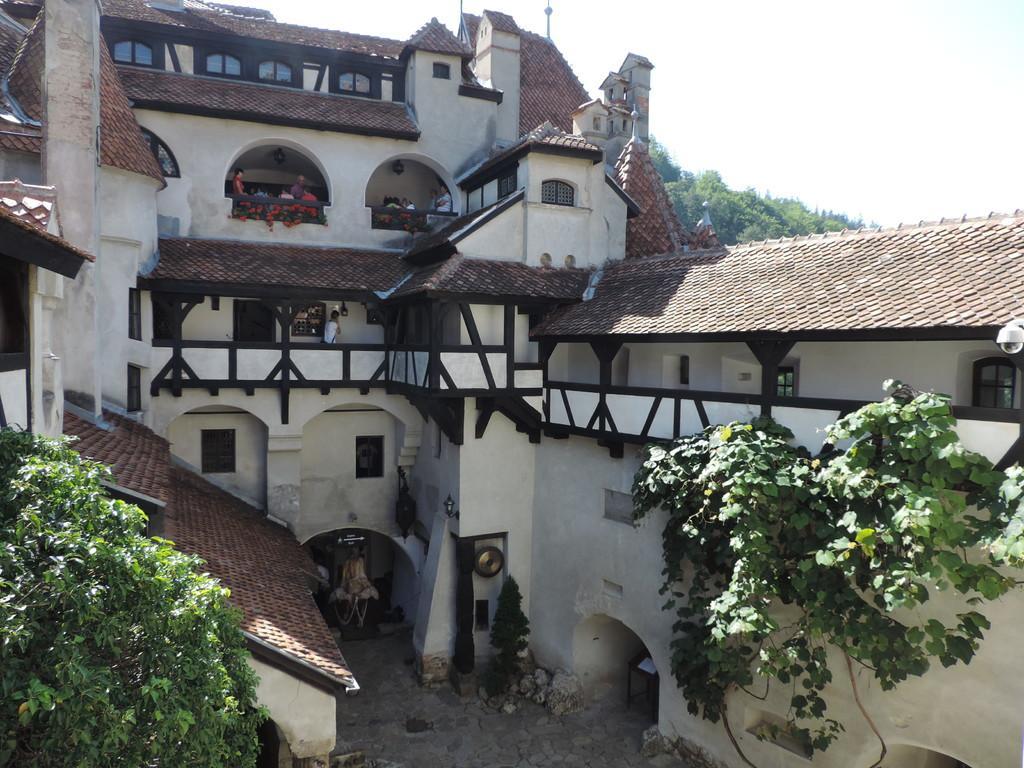In one or two sentences, can you explain what this image depicts? In this image we can see buildings, creepers, trees, stones, people standing in the balcony and sky. 